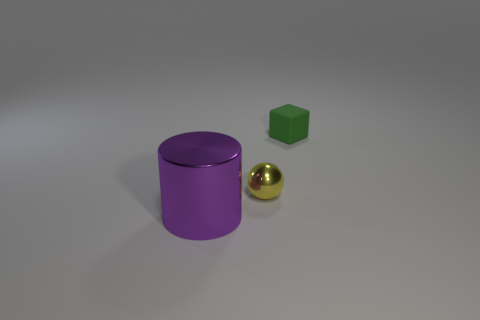Is there anything else that is made of the same material as the green object?
Offer a very short reply. No. How many tiny shiny spheres are on the left side of the thing that is behind the metallic thing to the right of the big object?
Provide a succinct answer. 1. Are there any big purple metal cylinders in front of the tiny yellow sphere?
Your response must be concise. Yes. What shape is the small metallic thing?
Your answer should be very brief. Sphere. The tiny thing on the left side of the object behind the small thing on the left side of the green rubber cube is what shape?
Provide a short and direct response. Sphere. How many other objects are there of the same shape as the tiny yellow object?
Make the answer very short. 0. What material is the thing that is in front of the tiny thing that is in front of the tiny green rubber object?
Your answer should be compact. Metal. Are there any other things that have the same size as the shiny cylinder?
Provide a short and direct response. No. Is the material of the tiny yellow thing the same as the object that is in front of the yellow shiny object?
Provide a short and direct response. Yes. What is the material of the thing that is behind the purple metallic thing and on the left side of the rubber block?
Ensure brevity in your answer.  Metal. 